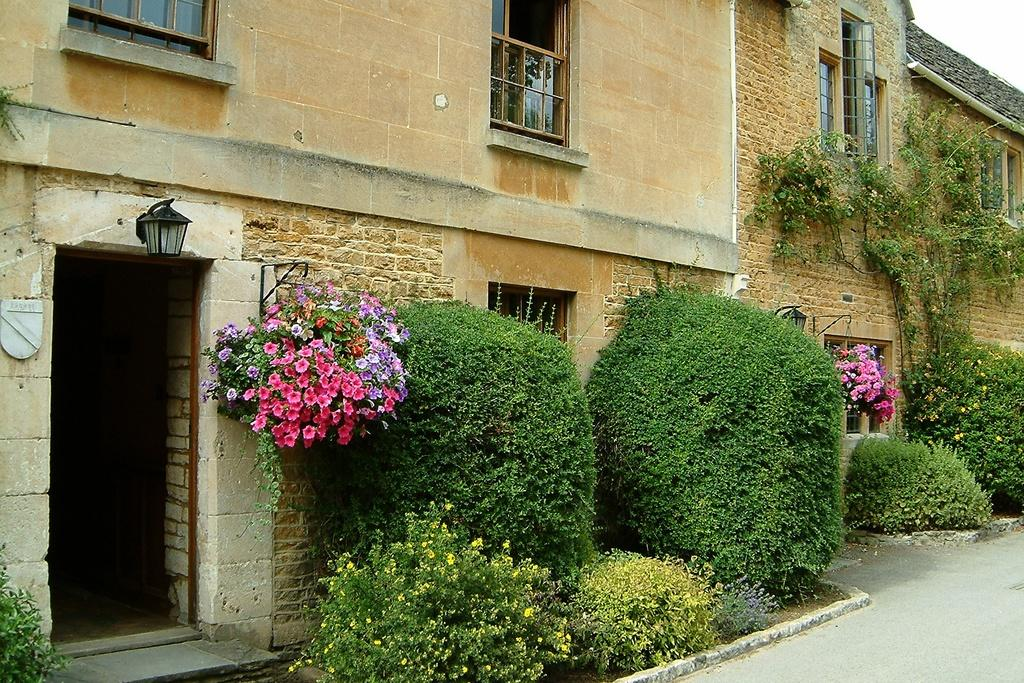Who or what can be seen in the image? There are people in the image. What else is present in the image besides people? There are plants and flowers in the image. What is the surface that the people and plants are standing on? The ground is visible in the image. Are there any artificial light sources in the image? Yes, there are lights in the image. Where is the carriage located in the image? There is no carriage present in the image. What type of field can be seen in the image? There is no field present in the image. 